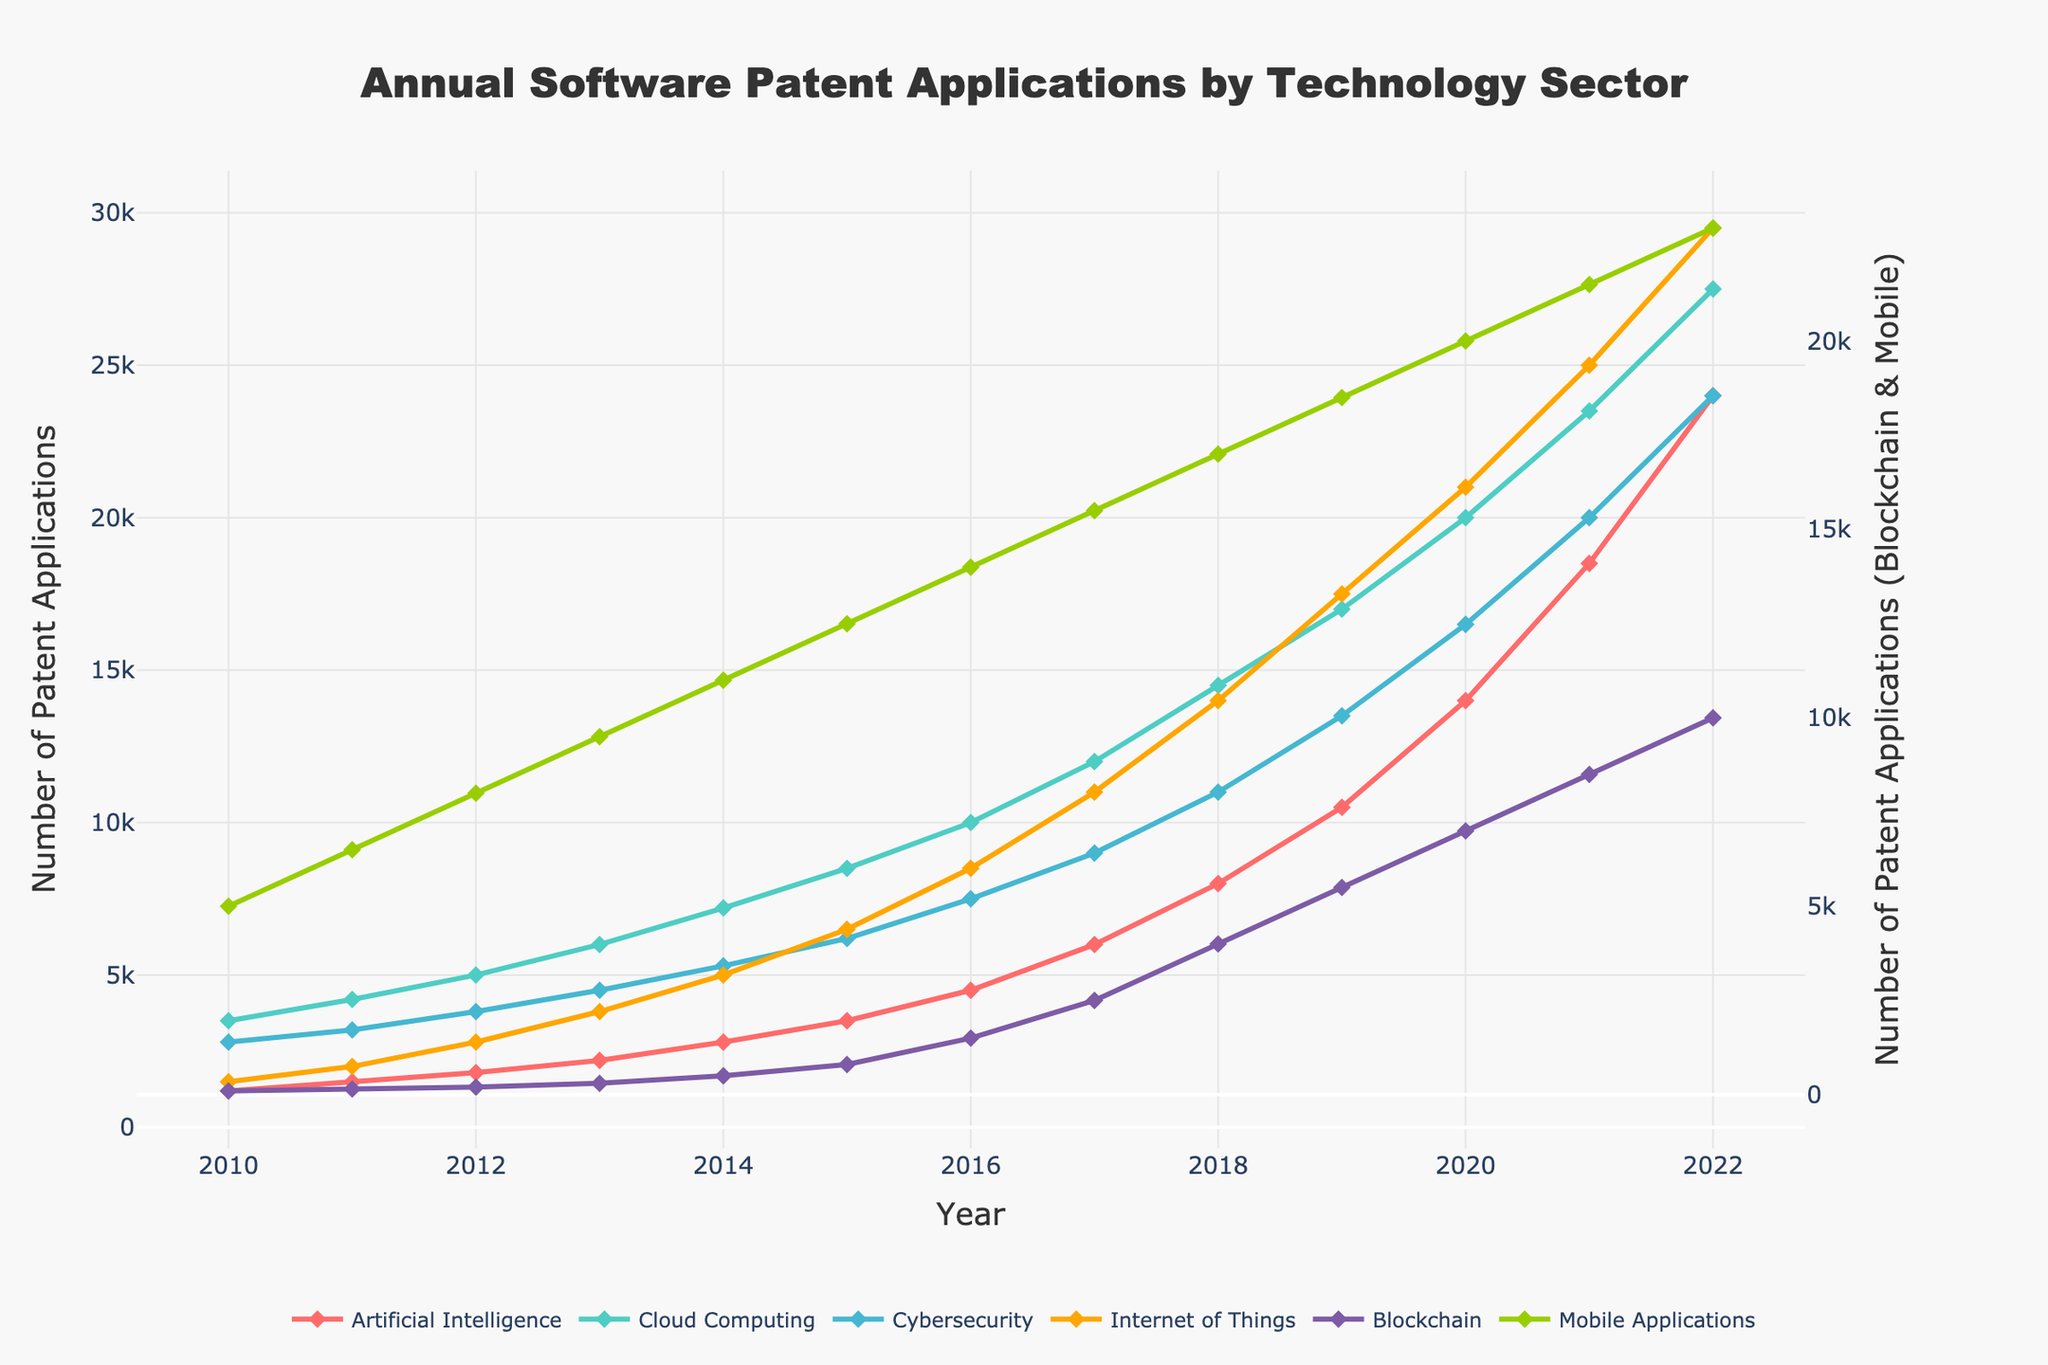What is the trend of patent applications in the Artificial Intelligence sector from 2010 to 2022? The number of patent applications in the Artificial Intelligence sector consistently increases every year from 1200 in 2010 to 24000 in 2022.
Answer: Consistent increase Which technology sector showed the highest number of patent applications in 2022, and what was the number? The Internet of Things sector showed the highest number of patent applications in 2022 with 29500 applications.
Answer: Internet of Things, 29500 Compare the growth in patent applications for Blockchain and Mobile Applications sectors between 2010 and 2020. Which one grew more? In 2010, Blockchain had 100 applications and Mobile Applications had 5000. In 2020, Blockchain had 7000 applications and Mobile Applications had 20000. The growth in Blockchain is 7000 - 100 = 6900 applications whereas in Mobile Applications it is 20000 - 5000 = 15000 applications. Therefore, Mobile Applications grew more.
Answer: Mobile Applications In what year did the Cybersecurity sector surpass 10000 patent applications? Looking at the trend, the Cybersecurity sector surpassed 10000 patent applications in the year 2017.
Answer: 2017 What is the difference in the number of patent applications between Artificial Intelligence and Cloud Computing in the year 2015? In 2015, Artificial Intelligence had 3500 applications and Cloud Computing had 8500 applications. The difference is 8500 - 3500 = 5000 applications.
Answer: 5000 Which sector showed the most rapid increase in patent applications between the years 2019 and 2022? Compare the slopes between 2019 and 2022 for all sectors and notice the most significant change. Internet of Things increased from 17500 to 29500, an increase of 12000. This is the largest among all sectors.
Answer: Internet of Things What is the average number of patent applications for Cloud Computing from 2010 to 2022? Sum up all the patent applications for Cloud Computing and divide by the number of years (13). (3500+4200+5000+6000+7200+8500+10000+12000+14500+17000+20000+23500+27500) / 13 = 13915.38
Answer: 13915.38 How does the trend in Mobile Applications compare visually to the trend in Cybersecurity? Both show an upward trend, but Mobile Applications have a consistently higher count and a slightly smoother upward trajectory compared to Cybersecurity, which shows more annual fluctuations.
Answer: Upward, Mobile higher Which sectors had patent applications exceeding 20000 in 2021, and how many were there for each? In 2021, Cloud Computing had 23500 applications, Cybersecurity had 20000, Internet of Things had 25000, and Mobile Applications had 21500.
Answer: Cloud Computing: 23500, Cybersecurity: 20000, IoT: 25000, Mobile Applications: 21500 